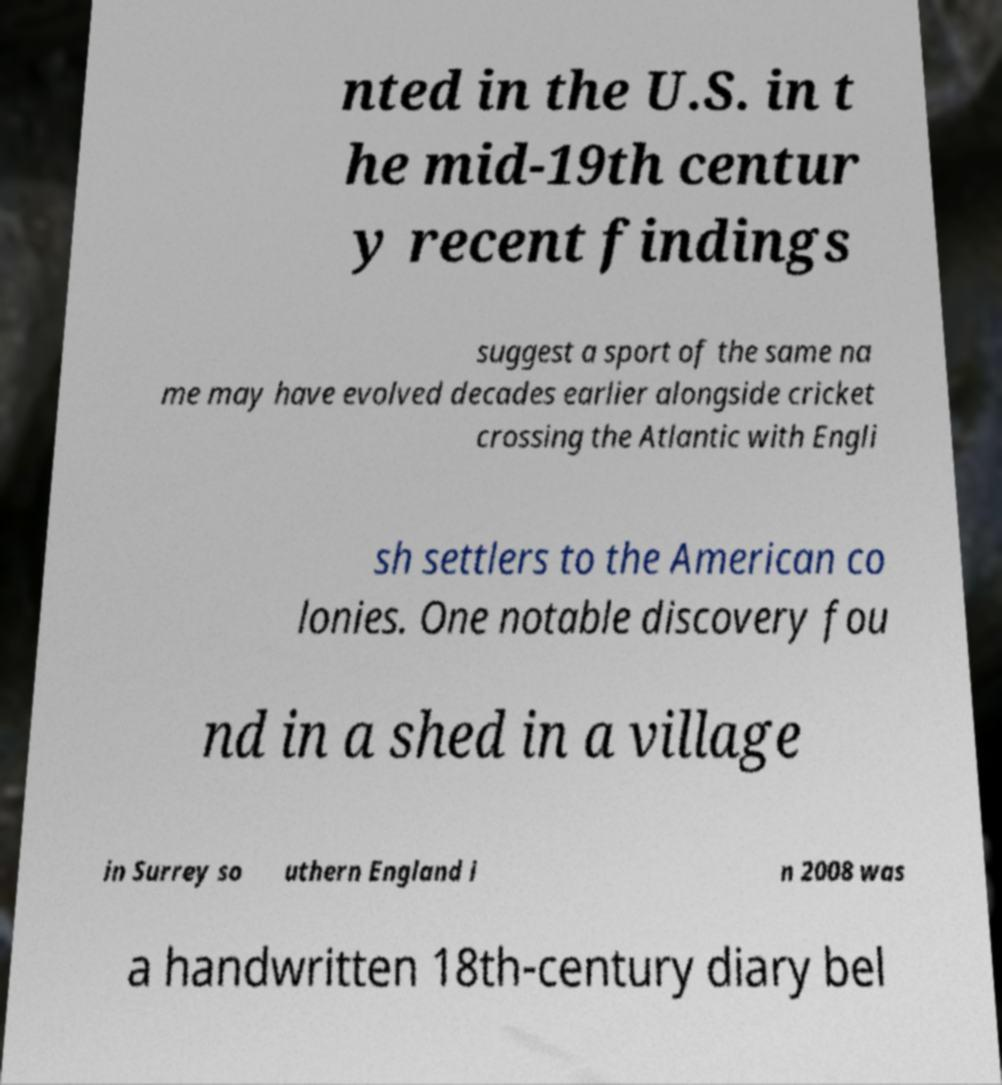There's text embedded in this image that I need extracted. Can you transcribe it verbatim? nted in the U.S. in t he mid-19th centur y recent findings suggest a sport of the same na me may have evolved decades earlier alongside cricket crossing the Atlantic with Engli sh settlers to the American co lonies. One notable discovery fou nd in a shed in a village in Surrey so uthern England i n 2008 was a handwritten 18th-century diary bel 